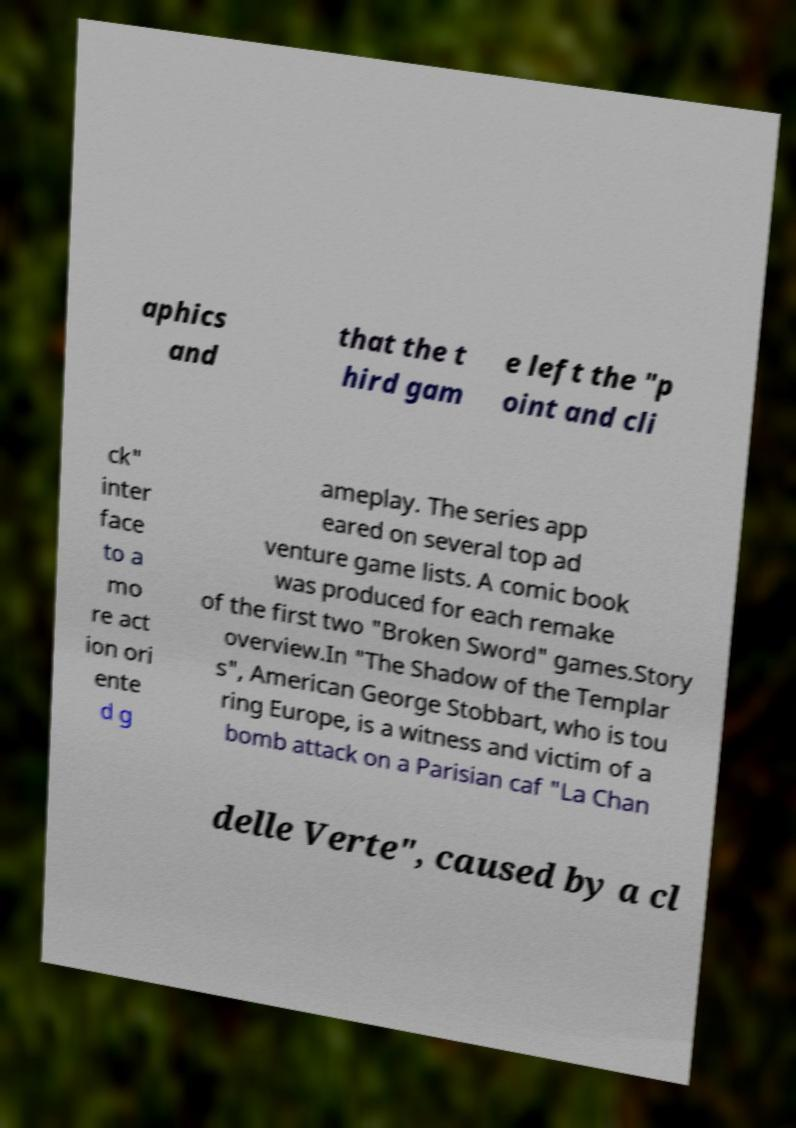For documentation purposes, I need the text within this image transcribed. Could you provide that? aphics and that the t hird gam e left the "p oint and cli ck" inter face to a mo re act ion ori ente d g ameplay. The series app eared on several top ad venture game lists. A comic book was produced for each remake of the first two "Broken Sword" games.Story overview.In "The Shadow of the Templar s", American George Stobbart, who is tou ring Europe, is a witness and victim of a bomb attack on a Parisian caf "La Chan delle Verte", caused by a cl 